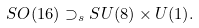<formula> <loc_0><loc_0><loc_500><loc_500>S O ( 1 6 ) \supset _ { s } S U ( 8 ) \times U ( 1 ) .</formula> 